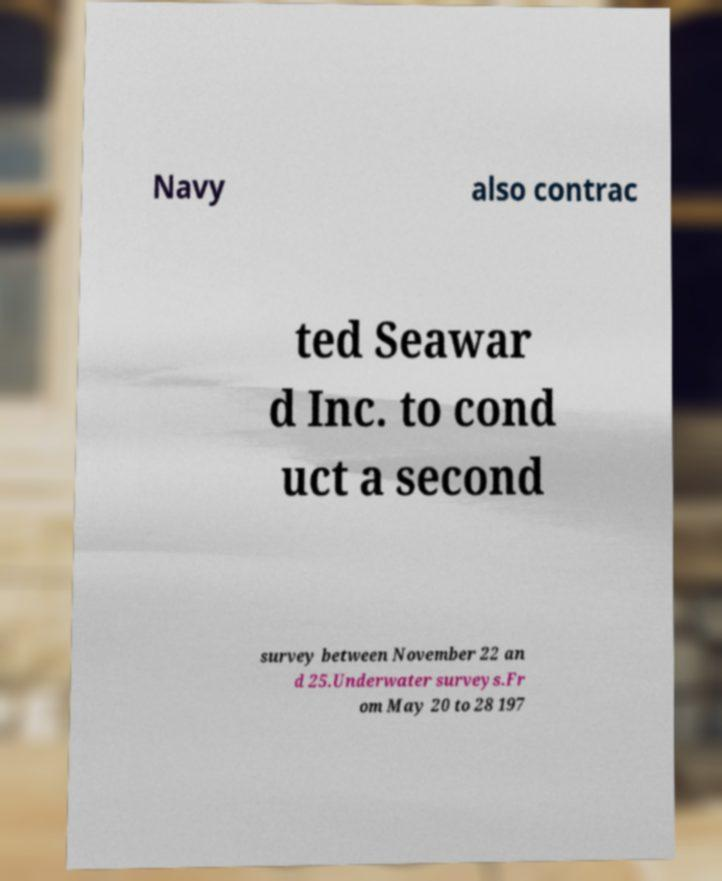There's text embedded in this image that I need extracted. Can you transcribe it verbatim? Navy also contrac ted Seawar d Inc. to cond uct a second survey between November 22 an d 25.Underwater surveys.Fr om May 20 to 28 197 